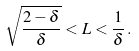<formula> <loc_0><loc_0><loc_500><loc_500>\sqrt { \frac { 2 - \delta } { \delta } } < L < \frac { 1 } { \delta } \, .</formula> 